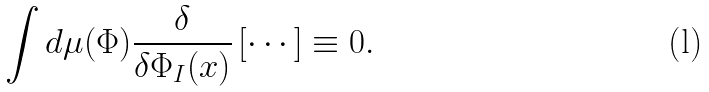Convert formula to latex. <formula><loc_0><loc_0><loc_500><loc_500>\int d \mu ( \Phi ) \frac { \delta } { \delta \Phi _ { I } ( x ) } \left [ \cdots \right ] \equiv 0 .</formula> 